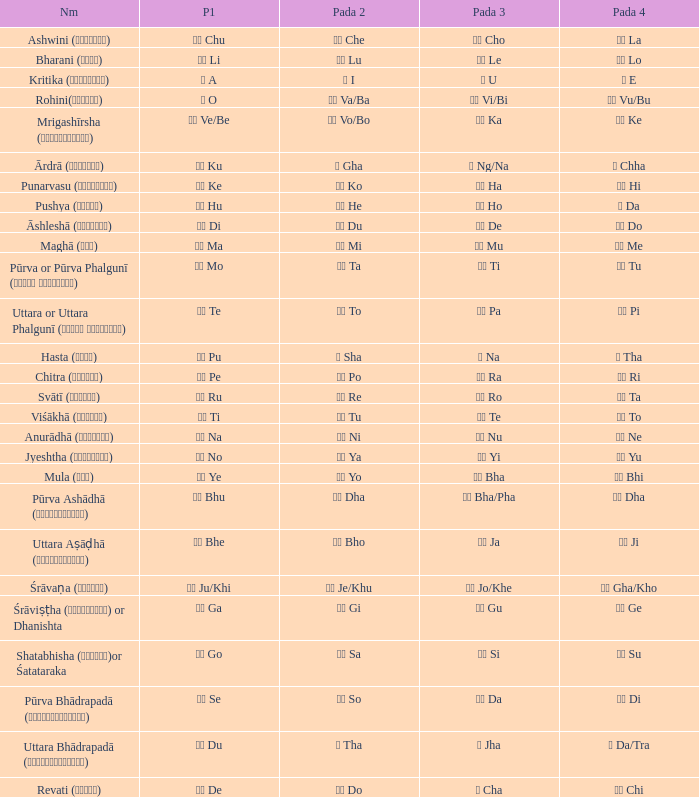What kind of Pada 1 has a Pada 2 of सा sa? गो Go. 